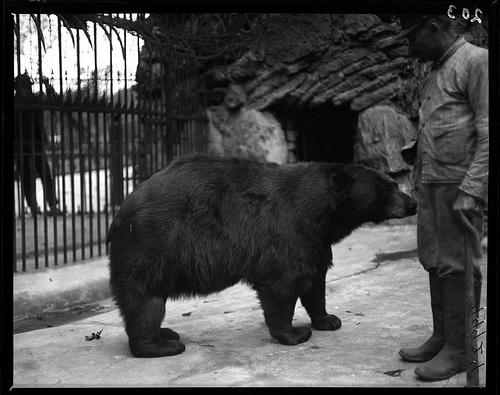What kind of bear is this?
Write a very short answer. Black. Is the bear in its natural habitat?
Answer briefly. No. What is the bear doing?
Answer briefly. Sniffing man. What species of bear is this?
Quick response, please. Brown. What is the color of the bear?
Short answer required. Black. Does the man appear to be afraid of the bear?
Write a very short answer. No. 